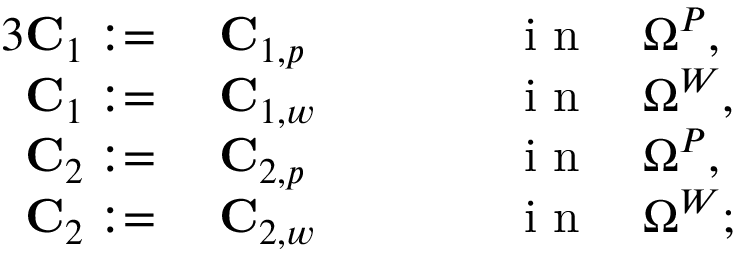Convert formula to latex. <formula><loc_0><loc_0><loc_500><loc_500>\begin{array} { r l r l } { { 3 } C _ { 1 } \colon = } & C _ { 1 , p } \quad } & i n \quad \Omega ^ { P } , } \\ { C _ { 1 } \colon = } & C _ { 1 , w } \quad } & i n \quad \Omega ^ { W } , } \\ { C _ { 2 } \colon = } & C _ { 2 , p } \quad } & i n \quad \Omega ^ { P } , } \\ { C _ { 2 } \colon = } & C _ { 2 , w } \quad } & i n \quad \Omega ^ { W } ; } \end{array}</formula> 